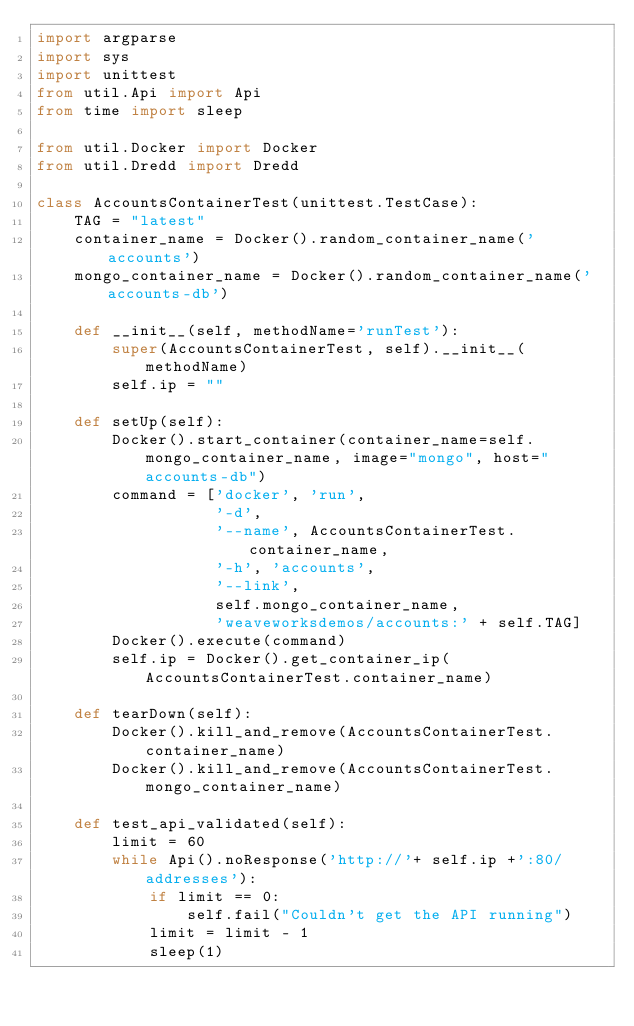<code> <loc_0><loc_0><loc_500><loc_500><_Python_>import argparse
import sys
import unittest
from util.Api import Api
from time import sleep

from util.Docker import Docker
from util.Dredd import Dredd

class AccountsContainerTest(unittest.TestCase):
    TAG = "latest"
    container_name = Docker().random_container_name('accounts')
    mongo_container_name = Docker().random_container_name('accounts-db')
    
    def __init__(self, methodName='runTest'):
        super(AccountsContainerTest, self).__init__(methodName)
        self.ip = ""

    def setUp(self):
        Docker().start_container(container_name=self.mongo_container_name, image="mongo", host="accounts-db")
        command = ['docker', 'run',
                   '-d',
                   '--name', AccountsContainerTest.container_name,
                   '-h', 'accounts',
                   '--link',
                   self.mongo_container_name,
                   'weaveworksdemos/accounts:' + self.TAG]
        Docker().execute(command)
        self.ip = Docker().get_container_ip(AccountsContainerTest.container_name)

    def tearDown(self):
        Docker().kill_and_remove(AccountsContainerTest.container_name)
        Docker().kill_and_remove(AccountsContainerTest.mongo_container_name)

    def test_api_validated(self):
        limit = 60
        while Api().noResponse('http://'+ self.ip +':80/addresses'):
            if limit == 0:
                self.fail("Couldn't get the API running")
            limit = limit - 1
            sleep(1)</code> 